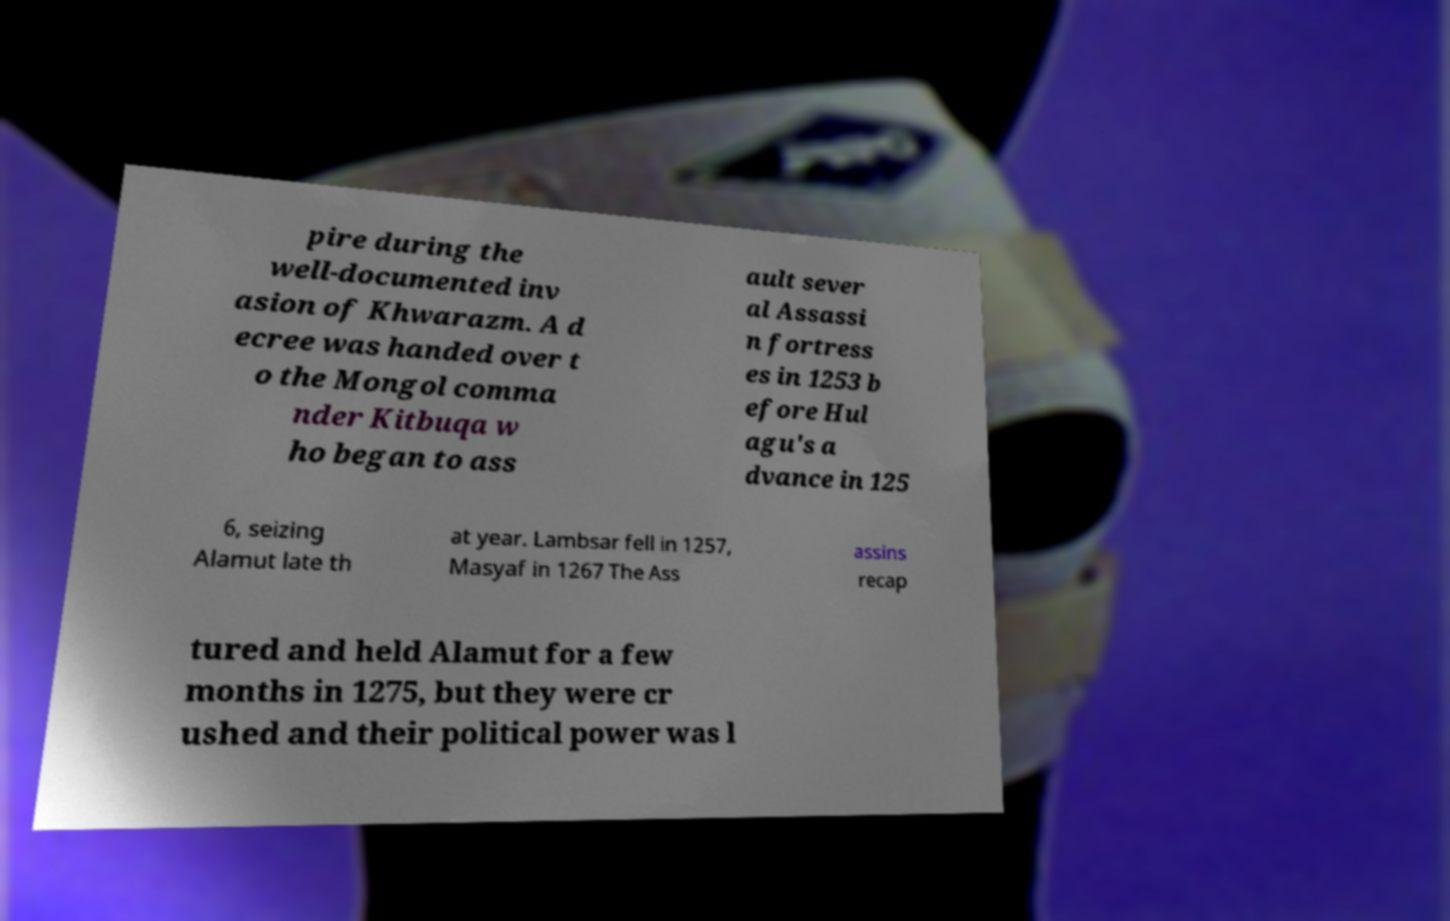For documentation purposes, I need the text within this image transcribed. Could you provide that? pire during the well-documented inv asion of Khwarazm. A d ecree was handed over t o the Mongol comma nder Kitbuqa w ho began to ass ault sever al Assassi n fortress es in 1253 b efore Hul agu's a dvance in 125 6, seizing Alamut late th at year. Lambsar fell in 1257, Masyaf in 1267 The Ass assins recap tured and held Alamut for a few months in 1275, but they were cr ushed and their political power was l 